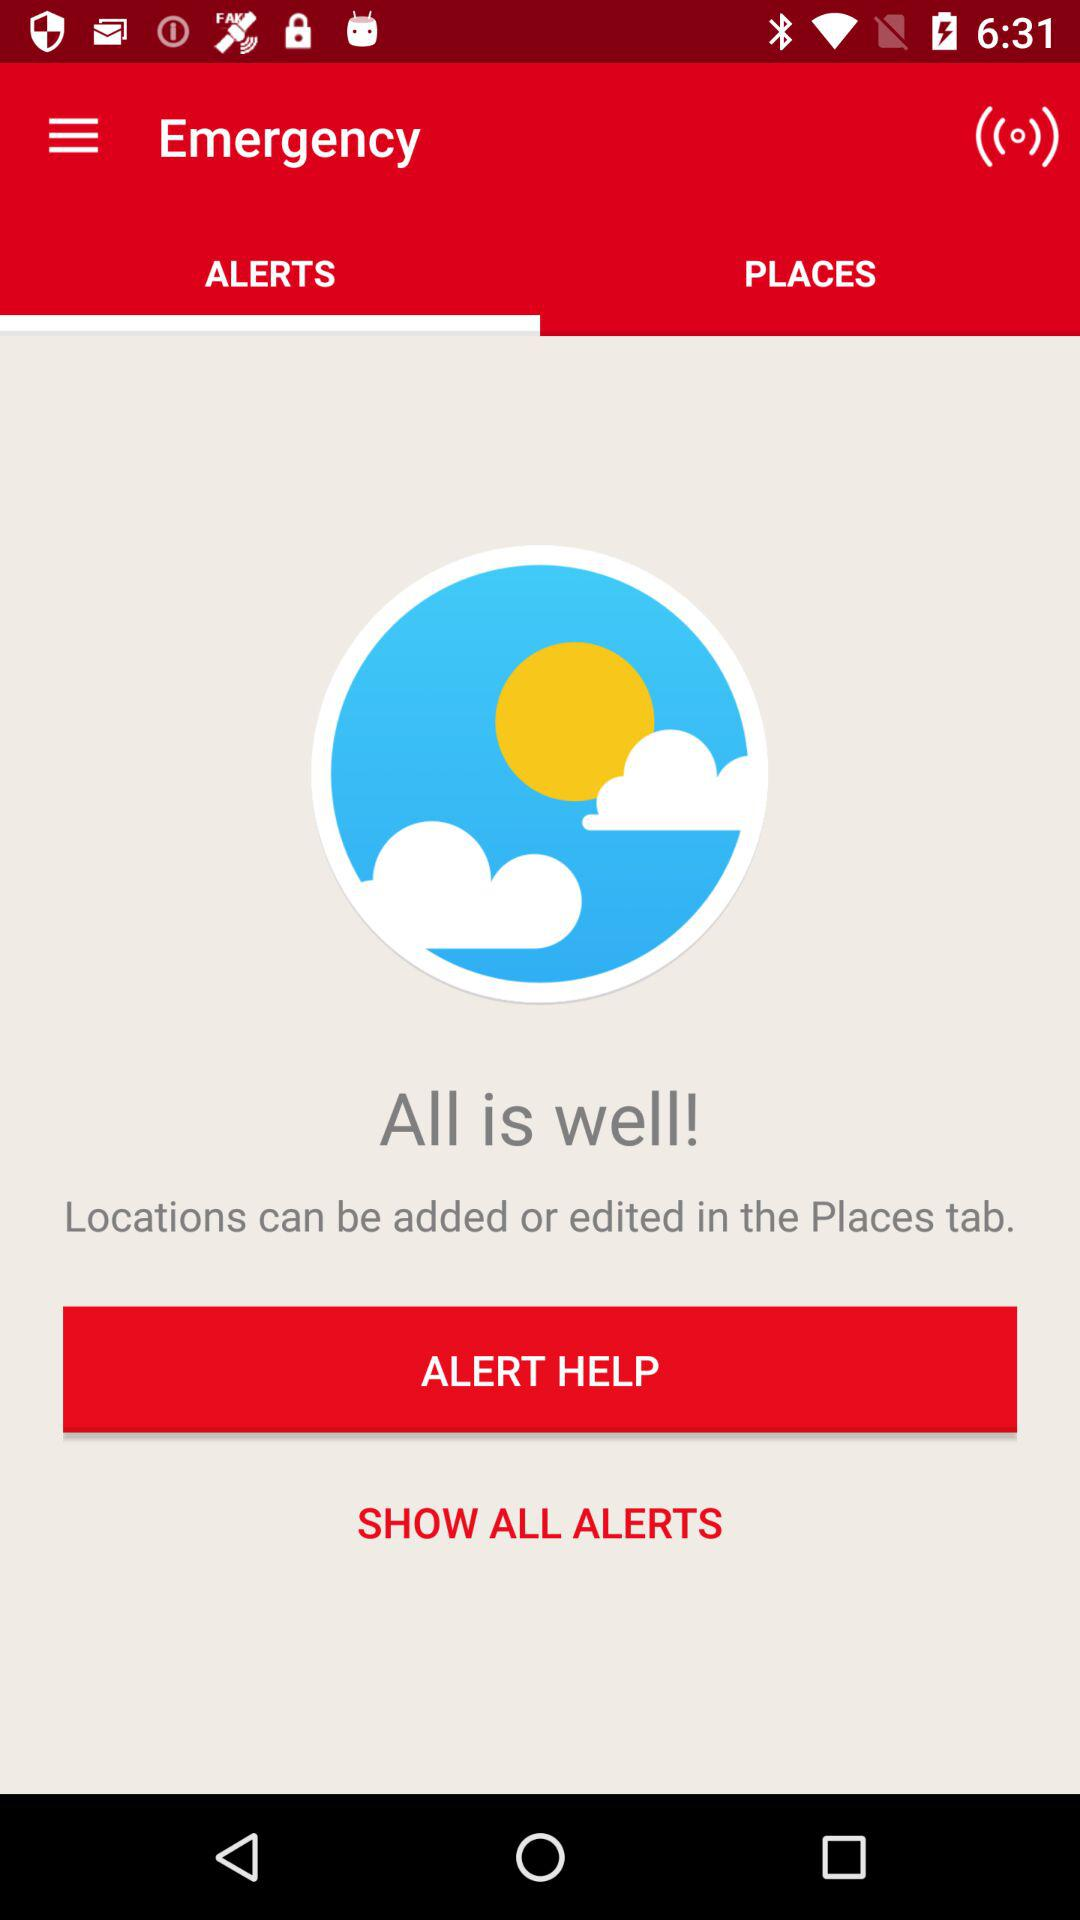How many tabs are there?
Answer the question using a single word or phrase. 2 